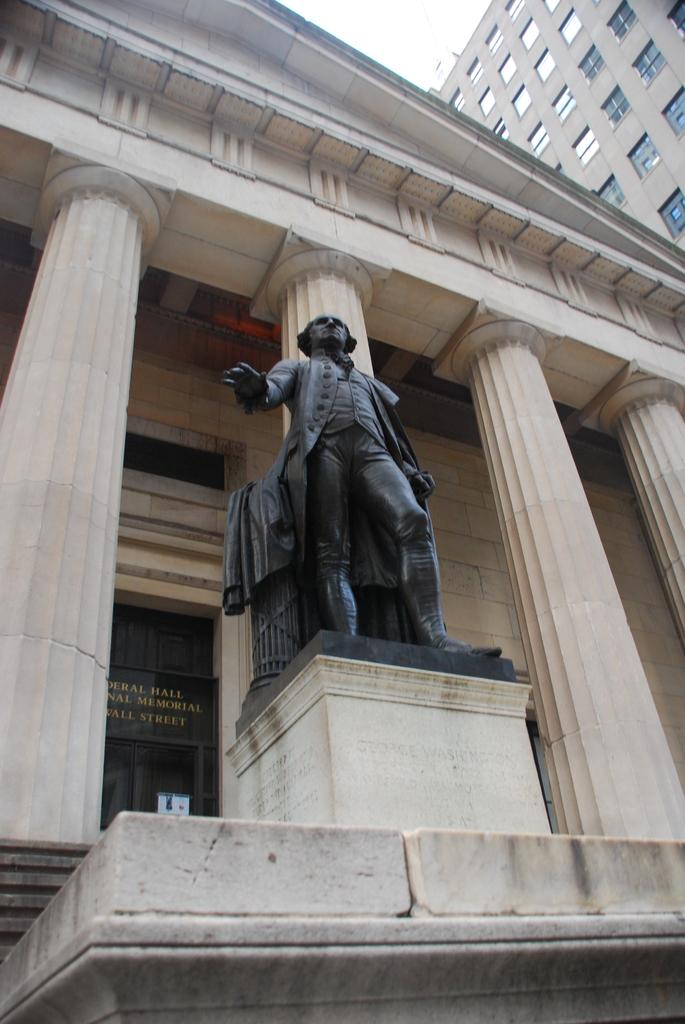What is the main subject in the image? There is a statue of a person in the image. What can be seen in the background of the image? There are pillars, buildings, and the sky visible in the background of the image. How does the earth interact with the statue in the image? The image does not show the earth interacting with the statue, as the statue is a stationary object and the earth is not depicted in the image. 